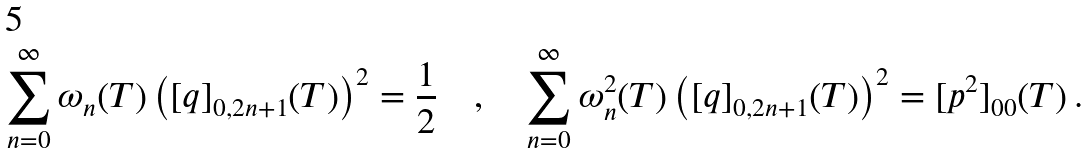<formula> <loc_0><loc_0><loc_500><loc_500>\sum _ { n = 0 } ^ { \infty } \omega _ { n } ( T ) \left ( [ q ] _ { 0 , 2 n + 1 } ( T ) \right ) ^ { 2 } = \frac { 1 } { 2 } \quad , \quad \sum _ { n = 0 } ^ { \infty } \omega _ { n } ^ { 2 } ( T ) \left ( [ q ] _ { 0 , 2 n + 1 } ( T ) \right ) ^ { 2 } = [ p ^ { 2 } ] _ { 0 0 } ( T ) \, .</formula> 